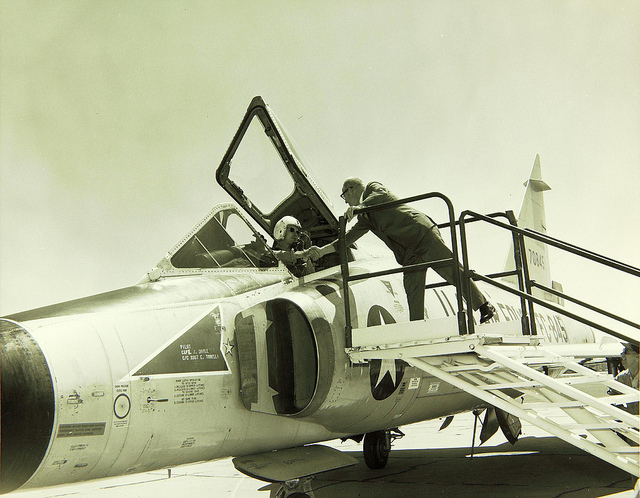<image>How is the airplane powered? It is ambiguous to confirm how the airplane is powered without more specific information. However, possible sources could include jet fuel, diesel, or gas. How is the airplane powered? I don't know how the airplane is powered. It can be powered by gas, fuel, diesel, or jet fuel. 